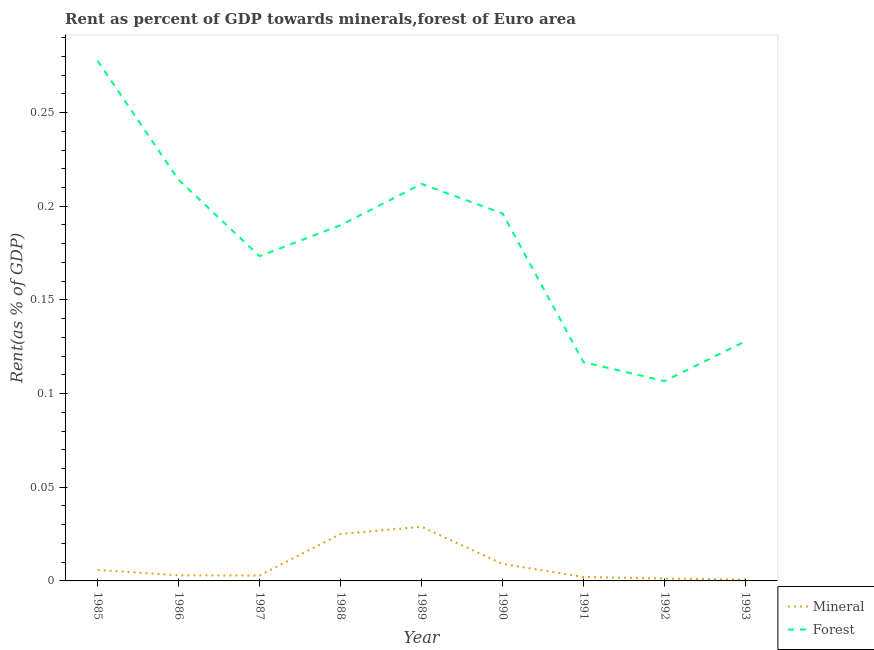How many different coloured lines are there?
Your answer should be very brief. 2. What is the forest rent in 1986?
Your answer should be compact. 0.21. Across all years, what is the maximum forest rent?
Provide a succinct answer. 0.28. Across all years, what is the minimum forest rent?
Your answer should be compact. 0.11. In which year was the mineral rent maximum?
Offer a terse response. 1989. What is the total mineral rent in the graph?
Offer a very short reply. 0.08. What is the difference between the mineral rent in 1986 and that in 1987?
Give a very brief answer. 0. What is the difference between the mineral rent in 1989 and the forest rent in 1988?
Your answer should be very brief. -0.16. What is the average forest rent per year?
Make the answer very short. 0.18. In the year 1993, what is the difference between the forest rent and mineral rent?
Keep it short and to the point. 0.13. In how many years, is the mineral rent greater than 0.18000000000000002 %?
Your answer should be very brief. 0. What is the ratio of the forest rent in 1986 to that in 1987?
Give a very brief answer. 1.23. Is the mineral rent in 1987 less than that in 1988?
Your answer should be compact. Yes. What is the difference between the highest and the second highest forest rent?
Ensure brevity in your answer.  0.06. What is the difference between the highest and the lowest forest rent?
Offer a terse response. 0.17. In how many years, is the forest rent greater than the average forest rent taken over all years?
Offer a very short reply. 5. Does the forest rent monotonically increase over the years?
Your answer should be very brief. No. Is the mineral rent strictly less than the forest rent over the years?
Your response must be concise. Yes. How many years are there in the graph?
Give a very brief answer. 9. Where does the legend appear in the graph?
Give a very brief answer. Bottom right. What is the title of the graph?
Offer a very short reply. Rent as percent of GDP towards minerals,forest of Euro area. What is the label or title of the Y-axis?
Your answer should be compact. Rent(as % of GDP). What is the Rent(as % of GDP) in Mineral in 1985?
Ensure brevity in your answer.  0.01. What is the Rent(as % of GDP) of Forest in 1985?
Make the answer very short. 0.28. What is the Rent(as % of GDP) of Mineral in 1986?
Your answer should be compact. 0. What is the Rent(as % of GDP) of Forest in 1986?
Your answer should be compact. 0.21. What is the Rent(as % of GDP) in Mineral in 1987?
Make the answer very short. 0. What is the Rent(as % of GDP) in Forest in 1987?
Your answer should be very brief. 0.17. What is the Rent(as % of GDP) of Mineral in 1988?
Keep it short and to the point. 0.03. What is the Rent(as % of GDP) of Forest in 1988?
Offer a very short reply. 0.19. What is the Rent(as % of GDP) in Mineral in 1989?
Make the answer very short. 0.03. What is the Rent(as % of GDP) of Forest in 1989?
Provide a succinct answer. 0.21. What is the Rent(as % of GDP) in Mineral in 1990?
Offer a terse response. 0.01. What is the Rent(as % of GDP) of Forest in 1990?
Ensure brevity in your answer.  0.2. What is the Rent(as % of GDP) of Mineral in 1991?
Keep it short and to the point. 0. What is the Rent(as % of GDP) of Forest in 1991?
Ensure brevity in your answer.  0.12. What is the Rent(as % of GDP) in Mineral in 1992?
Give a very brief answer. 0. What is the Rent(as % of GDP) in Forest in 1992?
Your answer should be very brief. 0.11. What is the Rent(as % of GDP) of Mineral in 1993?
Provide a short and direct response. 0. What is the Rent(as % of GDP) in Forest in 1993?
Provide a short and direct response. 0.13. Across all years, what is the maximum Rent(as % of GDP) of Mineral?
Your response must be concise. 0.03. Across all years, what is the maximum Rent(as % of GDP) in Forest?
Ensure brevity in your answer.  0.28. Across all years, what is the minimum Rent(as % of GDP) in Mineral?
Provide a succinct answer. 0. Across all years, what is the minimum Rent(as % of GDP) in Forest?
Provide a short and direct response. 0.11. What is the total Rent(as % of GDP) of Mineral in the graph?
Ensure brevity in your answer.  0.08. What is the total Rent(as % of GDP) of Forest in the graph?
Provide a short and direct response. 1.61. What is the difference between the Rent(as % of GDP) in Mineral in 1985 and that in 1986?
Provide a short and direct response. 0. What is the difference between the Rent(as % of GDP) in Forest in 1985 and that in 1986?
Make the answer very short. 0.06. What is the difference between the Rent(as % of GDP) in Mineral in 1985 and that in 1987?
Provide a short and direct response. 0. What is the difference between the Rent(as % of GDP) in Forest in 1985 and that in 1987?
Your answer should be compact. 0.1. What is the difference between the Rent(as % of GDP) in Mineral in 1985 and that in 1988?
Give a very brief answer. -0.02. What is the difference between the Rent(as % of GDP) in Forest in 1985 and that in 1988?
Provide a succinct answer. 0.09. What is the difference between the Rent(as % of GDP) in Mineral in 1985 and that in 1989?
Ensure brevity in your answer.  -0.02. What is the difference between the Rent(as % of GDP) of Forest in 1985 and that in 1989?
Offer a very short reply. 0.07. What is the difference between the Rent(as % of GDP) in Mineral in 1985 and that in 1990?
Ensure brevity in your answer.  -0. What is the difference between the Rent(as % of GDP) in Forest in 1985 and that in 1990?
Your response must be concise. 0.08. What is the difference between the Rent(as % of GDP) of Mineral in 1985 and that in 1991?
Offer a terse response. 0. What is the difference between the Rent(as % of GDP) of Forest in 1985 and that in 1991?
Offer a terse response. 0.16. What is the difference between the Rent(as % of GDP) of Mineral in 1985 and that in 1992?
Provide a succinct answer. 0. What is the difference between the Rent(as % of GDP) of Forest in 1985 and that in 1992?
Provide a short and direct response. 0.17. What is the difference between the Rent(as % of GDP) of Mineral in 1985 and that in 1993?
Provide a short and direct response. 0.01. What is the difference between the Rent(as % of GDP) in Forest in 1985 and that in 1993?
Ensure brevity in your answer.  0.15. What is the difference between the Rent(as % of GDP) of Mineral in 1986 and that in 1987?
Your response must be concise. 0. What is the difference between the Rent(as % of GDP) in Forest in 1986 and that in 1987?
Provide a succinct answer. 0.04. What is the difference between the Rent(as % of GDP) of Mineral in 1986 and that in 1988?
Your answer should be compact. -0.02. What is the difference between the Rent(as % of GDP) in Forest in 1986 and that in 1988?
Make the answer very short. 0.02. What is the difference between the Rent(as % of GDP) in Mineral in 1986 and that in 1989?
Provide a short and direct response. -0.03. What is the difference between the Rent(as % of GDP) in Forest in 1986 and that in 1989?
Your answer should be very brief. 0. What is the difference between the Rent(as % of GDP) in Mineral in 1986 and that in 1990?
Give a very brief answer. -0.01. What is the difference between the Rent(as % of GDP) of Forest in 1986 and that in 1990?
Make the answer very short. 0.02. What is the difference between the Rent(as % of GDP) of Mineral in 1986 and that in 1991?
Provide a succinct answer. 0. What is the difference between the Rent(as % of GDP) of Forest in 1986 and that in 1991?
Make the answer very short. 0.1. What is the difference between the Rent(as % of GDP) in Mineral in 1986 and that in 1992?
Your answer should be very brief. 0. What is the difference between the Rent(as % of GDP) in Forest in 1986 and that in 1992?
Offer a very short reply. 0.11. What is the difference between the Rent(as % of GDP) in Mineral in 1986 and that in 1993?
Keep it short and to the point. 0. What is the difference between the Rent(as % of GDP) of Forest in 1986 and that in 1993?
Offer a terse response. 0.09. What is the difference between the Rent(as % of GDP) of Mineral in 1987 and that in 1988?
Provide a succinct answer. -0.02. What is the difference between the Rent(as % of GDP) in Forest in 1987 and that in 1988?
Your answer should be very brief. -0.02. What is the difference between the Rent(as % of GDP) in Mineral in 1987 and that in 1989?
Provide a succinct answer. -0.03. What is the difference between the Rent(as % of GDP) of Forest in 1987 and that in 1989?
Give a very brief answer. -0.04. What is the difference between the Rent(as % of GDP) of Mineral in 1987 and that in 1990?
Keep it short and to the point. -0.01. What is the difference between the Rent(as % of GDP) in Forest in 1987 and that in 1990?
Provide a short and direct response. -0.02. What is the difference between the Rent(as % of GDP) in Mineral in 1987 and that in 1991?
Ensure brevity in your answer.  0. What is the difference between the Rent(as % of GDP) of Forest in 1987 and that in 1991?
Offer a very short reply. 0.06. What is the difference between the Rent(as % of GDP) in Mineral in 1987 and that in 1992?
Give a very brief answer. 0. What is the difference between the Rent(as % of GDP) in Forest in 1987 and that in 1992?
Keep it short and to the point. 0.07. What is the difference between the Rent(as % of GDP) in Mineral in 1987 and that in 1993?
Your answer should be very brief. 0. What is the difference between the Rent(as % of GDP) of Forest in 1987 and that in 1993?
Your answer should be compact. 0.05. What is the difference between the Rent(as % of GDP) of Mineral in 1988 and that in 1989?
Make the answer very short. -0. What is the difference between the Rent(as % of GDP) of Forest in 1988 and that in 1989?
Provide a short and direct response. -0.02. What is the difference between the Rent(as % of GDP) of Mineral in 1988 and that in 1990?
Offer a very short reply. 0.02. What is the difference between the Rent(as % of GDP) in Forest in 1988 and that in 1990?
Offer a very short reply. -0.01. What is the difference between the Rent(as % of GDP) in Mineral in 1988 and that in 1991?
Your answer should be very brief. 0.02. What is the difference between the Rent(as % of GDP) in Forest in 1988 and that in 1991?
Give a very brief answer. 0.07. What is the difference between the Rent(as % of GDP) in Mineral in 1988 and that in 1992?
Offer a terse response. 0.02. What is the difference between the Rent(as % of GDP) in Forest in 1988 and that in 1992?
Make the answer very short. 0.08. What is the difference between the Rent(as % of GDP) in Mineral in 1988 and that in 1993?
Your answer should be very brief. 0.02. What is the difference between the Rent(as % of GDP) of Forest in 1988 and that in 1993?
Provide a succinct answer. 0.06. What is the difference between the Rent(as % of GDP) in Mineral in 1989 and that in 1990?
Your answer should be very brief. 0.02. What is the difference between the Rent(as % of GDP) of Forest in 1989 and that in 1990?
Offer a terse response. 0.02. What is the difference between the Rent(as % of GDP) in Mineral in 1989 and that in 1991?
Offer a terse response. 0.03. What is the difference between the Rent(as % of GDP) in Forest in 1989 and that in 1991?
Offer a terse response. 0.1. What is the difference between the Rent(as % of GDP) in Mineral in 1989 and that in 1992?
Your response must be concise. 0.03. What is the difference between the Rent(as % of GDP) of Forest in 1989 and that in 1992?
Your answer should be compact. 0.11. What is the difference between the Rent(as % of GDP) in Mineral in 1989 and that in 1993?
Your answer should be compact. 0.03. What is the difference between the Rent(as % of GDP) of Forest in 1989 and that in 1993?
Give a very brief answer. 0.08. What is the difference between the Rent(as % of GDP) of Mineral in 1990 and that in 1991?
Give a very brief answer. 0.01. What is the difference between the Rent(as % of GDP) in Forest in 1990 and that in 1991?
Provide a short and direct response. 0.08. What is the difference between the Rent(as % of GDP) in Mineral in 1990 and that in 1992?
Give a very brief answer. 0.01. What is the difference between the Rent(as % of GDP) in Forest in 1990 and that in 1992?
Your answer should be compact. 0.09. What is the difference between the Rent(as % of GDP) in Mineral in 1990 and that in 1993?
Provide a short and direct response. 0.01. What is the difference between the Rent(as % of GDP) in Forest in 1990 and that in 1993?
Make the answer very short. 0.07. What is the difference between the Rent(as % of GDP) in Mineral in 1991 and that in 1992?
Your response must be concise. 0. What is the difference between the Rent(as % of GDP) of Forest in 1991 and that in 1992?
Your response must be concise. 0.01. What is the difference between the Rent(as % of GDP) in Mineral in 1991 and that in 1993?
Offer a terse response. 0. What is the difference between the Rent(as % of GDP) in Forest in 1991 and that in 1993?
Give a very brief answer. -0.01. What is the difference between the Rent(as % of GDP) in Mineral in 1992 and that in 1993?
Your answer should be very brief. 0. What is the difference between the Rent(as % of GDP) of Forest in 1992 and that in 1993?
Provide a succinct answer. -0.02. What is the difference between the Rent(as % of GDP) of Mineral in 1985 and the Rent(as % of GDP) of Forest in 1986?
Your answer should be very brief. -0.21. What is the difference between the Rent(as % of GDP) of Mineral in 1985 and the Rent(as % of GDP) of Forest in 1987?
Offer a very short reply. -0.17. What is the difference between the Rent(as % of GDP) of Mineral in 1985 and the Rent(as % of GDP) of Forest in 1988?
Make the answer very short. -0.18. What is the difference between the Rent(as % of GDP) of Mineral in 1985 and the Rent(as % of GDP) of Forest in 1989?
Offer a terse response. -0.21. What is the difference between the Rent(as % of GDP) of Mineral in 1985 and the Rent(as % of GDP) of Forest in 1990?
Make the answer very short. -0.19. What is the difference between the Rent(as % of GDP) of Mineral in 1985 and the Rent(as % of GDP) of Forest in 1991?
Your answer should be compact. -0.11. What is the difference between the Rent(as % of GDP) of Mineral in 1985 and the Rent(as % of GDP) of Forest in 1992?
Offer a terse response. -0.1. What is the difference between the Rent(as % of GDP) of Mineral in 1985 and the Rent(as % of GDP) of Forest in 1993?
Keep it short and to the point. -0.12. What is the difference between the Rent(as % of GDP) in Mineral in 1986 and the Rent(as % of GDP) in Forest in 1987?
Offer a terse response. -0.17. What is the difference between the Rent(as % of GDP) of Mineral in 1986 and the Rent(as % of GDP) of Forest in 1988?
Provide a succinct answer. -0.19. What is the difference between the Rent(as % of GDP) in Mineral in 1986 and the Rent(as % of GDP) in Forest in 1989?
Keep it short and to the point. -0.21. What is the difference between the Rent(as % of GDP) of Mineral in 1986 and the Rent(as % of GDP) of Forest in 1990?
Your answer should be compact. -0.19. What is the difference between the Rent(as % of GDP) in Mineral in 1986 and the Rent(as % of GDP) in Forest in 1991?
Offer a very short reply. -0.11. What is the difference between the Rent(as % of GDP) of Mineral in 1986 and the Rent(as % of GDP) of Forest in 1992?
Give a very brief answer. -0.1. What is the difference between the Rent(as % of GDP) in Mineral in 1986 and the Rent(as % of GDP) in Forest in 1993?
Offer a very short reply. -0.12. What is the difference between the Rent(as % of GDP) of Mineral in 1987 and the Rent(as % of GDP) of Forest in 1988?
Your answer should be compact. -0.19. What is the difference between the Rent(as % of GDP) in Mineral in 1987 and the Rent(as % of GDP) in Forest in 1989?
Ensure brevity in your answer.  -0.21. What is the difference between the Rent(as % of GDP) of Mineral in 1987 and the Rent(as % of GDP) of Forest in 1990?
Keep it short and to the point. -0.19. What is the difference between the Rent(as % of GDP) in Mineral in 1987 and the Rent(as % of GDP) in Forest in 1991?
Provide a short and direct response. -0.11. What is the difference between the Rent(as % of GDP) in Mineral in 1987 and the Rent(as % of GDP) in Forest in 1992?
Make the answer very short. -0.1. What is the difference between the Rent(as % of GDP) of Mineral in 1987 and the Rent(as % of GDP) of Forest in 1993?
Your answer should be very brief. -0.13. What is the difference between the Rent(as % of GDP) in Mineral in 1988 and the Rent(as % of GDP) in Forest in 1989?
Provide a succinct answer. -0.19. What is the difference between the Rent(as % of GDP) of Mineral in 1988 and the Rent(as % of GDP) of Forest in 1990?
Your response must be concise. -0.17. What is the difference between the Rent(as % of GDP) in Mineral in 1988 and the Rent(as % of GDP) in Forest in 1991?
Offer a very short reply. -0.09. What is the difference between the Rent(as % of GDP) in Mineral in 1988 and the Rent(as % of GDP) in Forest in 1992?
Your response must be concise. -0.08. What is the difference between the Rent(as % of GDP) of Mineral in 1988 and the Rent(as % of GDP) of Forest in 1993?
Your answer should be very brief. -0.1. What is the difference between the Rent(as % of GDP) in Mineral in 1989 and the Rent(as % of GDP) in Forest in 1990?
Your response must be concise. -0.17. What is the difference between the Rent(as % of GDP) in Mineral in 1989 and the Rent(as % of GDP) in Forest in 1991?
Your answer should be compact. -0.09. What is the difference between the Rent(as % of GDP) of Mineral in 1989 and the Rent(as % of GDP) of Forest in 1992?
Give a very brief answer. -0.08. What is the difference between the Rent(as % of GDP) in Mineral in 1989 and the Rent(as % of GDP) in Forest in 1993?
Make the answer very short. -0.1. What is the difference between the Rent(as % of GDP) of Mineral in 1990 and the Rent(as % of GDP) of Forest in 1991?
Keep it short and to the point. -0.11. What is the difference between the Rent(as % of GDP) of Mineral in 1990 and the Rent(as % of GDP) of Forest in 1992?
Provide a succinct answer. -0.1. What is the difference between the Rent(as % of GDP) of Mineral in 1990 and the Rent(as % of GDP) of Forest in 1993?
Make the answer very short. -0.12. What is the difference between the Rent(as % of GDP) in Mineral in 1991 and the Rent(as % of GDP) in Forest in 1992?
Provide a succinct answer. -0.1. What is the difference between the Rent(as % of GDP) of Mineral in 1991 and the Rent(as % of GDP) of Forest in 1993?
Provide a succinct answer. -0.13. What is the difference between the Rent(as % of GDP) in Mineral in 1992 and the Rent(as % of GDP) in Forest in 1993?
Your answer should be very brief. -0.13. What is the average Rent(as % of GDP) of Mineral per year?
Ensure brevity in your answer.  0.01. What is the average Rent(as % of GDP) in Forest per year?
Your answer should be compact. 0.18. In the year 1985, what is the difference between the Rent(as % of GDP) in Mineral and Rent(as % of GDP) in Forest?
Offer a terse response. -0.27. In the year 1986, what is the difference between the Rent(as % of GDP) of Mineral and Rent(as % of GDP) of Forest?
Your answer should be compact. -0.21. In the year 1987, what is the difference between the Rent(as % of GDP) of Mineral and Rent(as % of GDP) of Forest?
Offer a terse response. -0.17. In the year 1988, what is the difference between the Rent(as % of GDP) in Mineral and Rent(as % of GDP) in Forest?
Ensure brevity in your answer.  -0.16. In the year 1989, what is the difference between the Rent(as % of GDP) in Mineral and Rent(as % of GDP) in Forest?
Provide a succinct answer. -0.18. In the year 1990, what is the difference between the Rent(as % of GDP) in Mineral and Rent(as % of GDP) in Forest?
Give a very brief answer. -0.19. In the year 1991, what is the difference between the Rent(as % of GDP) of Mineral and Rent(as % of GDP) of Forest?
Offer a very short reply. -0.11. In the year 1992, what is the difference between the Rent(as % of GDP) in Mineral and Rent(as % of GDP) in Forest?
Keep it short and to the point. -0.11. In the year 1993, what is the difference between the Rent(as % of GDP) of Mineral and Rent(as % of GDP) of Forest?
Offer a very short reply. -0.13. What is the ratio of the Rent(as % of GDP) in Mineral in 1985 to that in 1986?
Offer a terse response. 1.95. What is the ratio of the Rent(as % of GDP) of Forest in 1985 to that in 1986?
Provide a succinct answer. 1.3. What is the ratio of the Rent(as % of GDP) in Mineral in 1985 to that in 1987?
Offer a very short reply. 2.03. What is the ratio of the Rent(as % of GDP) in Forest in 1985 to that in 1987?
Make the answer very short. 1.6. What is the ratio of the Rent(as % of GDP) of Mineral in 1985 to that in 1988?
Offer a terse response. 0.23. What is the ratio of the Rent(as % of GDP) in Forest in 1985 to that in 1988?
Give a very brief answer. 1.46. What is the ratio of the Rent(as % of GDP) of Mineral in 1985 to that in 1989?
Provide a short and direct response. 0.2. What is the ratio of the Rent(as % of GDP) of Forest in 1985 to that in 1989?
Provide a short and direct response. 1.31. What is the ratio of the Rent(as % of GDP) in Mineral in 1985 to that in 1990?
Provide a succinct answer. 0.64. What is the ratio of the Rent(as % of GDP) in Forest in 1985 to that in 1990?
Provide a succinct answer. 1.42. What is the ratio of the Rent(as % of GDP) in Mineral in 1985 to that in 1991?
Your answer should be very brief. 2.77. What is the ratio of the Rent(as % of GDP) in Forest in 1985 to that in 1991?
Keep it short and to the point. 2.38. What is the ratio of the Rent(as % of GDP) of Mineral in 1985 to that in 1992?
Give a very brief answer. 4.55. What is the ratio of the Rent(as % of GDP) of Forest in 1985 to that in 1992?
Give a very brief answer. 2.6. What is the ratio of the Rent(as % of GDP) of Mineral in 1985 to that in 1993?
Offer a terse response. 8.27. What is the ratio of the Rent(as % of GDP) in Forest in 1985 to that in 1993?
Keep it short and to the point. 2.17. What is the ratio of the Rent(as % of GDP) in Mineral in 1986 to that in 1987?
Provide a short and direct response. 1.04. What is the ratio of the Rent(as % of GDP) in Forest in 1986 to that in 1987?
Provide a succinct answer. 1.23. What is the ratio of the Rent(as % of GDP) of Mineral in 1986 to that in 1988?
Make the answer very short. 0.12. What is the ratio of the Rent(as % of GDP) of Forest in 1986 to that in 1988?
Make the answer very short. 1.13. What is the ratio of the Rent(as % of GDP) in Mineral in 1986 to that in 1989?
Provide a succinct answer. 0.1. What is the ratio of the Rent(as % of GDP) of Forest in 1986 to that in 1989?
Offer a very short reply. 1.01. What is the ratio of the Rent(as % of GDP) in Mineral in 1986 to that in 1990?
Provide a succinct answer. 0.33. What is the ratio of the Rent(as % of GDP) of Forest in 1986 to that in 1990?
Make the answer very short. 1.09. What is the ratio of the Rent(as % of GDP) in Mineral in 1986 to that in 1991?
Offer a very short reply. 1.42. What is the ratio of the Rent(as % of GDP) in Forest in 1986 to that in 1991?
Your answer should be compact. 1.83. What is the ratio of the Rent(as % of GDP) of Mineral in 1986 to that in 1992?
Provide a short and direct response. 2.34. What is the ratio of the Rent(as % of GDP) of Forest in 1986 to that in 1992?
Provide a succinct answer. 2.01. What is the ratio of the Rent(as % of GDP) in Mineral in 1986 to that in 1993?
Provide a short and direct response. 4.25. What is the ratio of the Rent(as % of GDP) in Forest in 1986 to that in 1993?
Provide a short and direct response. 1.67. What is the ratio of the Rent(as % of GDP) in Mineral in 1987 to that in 1988?
Keep it short and to the point. 0.12. What is the ratio of the Rent(as % of GDP) of Forest in 1987 to that in 1988?
Provide a short and direct response. 0.91. What is the ratio of the Rent(as % of GDP) in Mineral in 1987 to that in 1989?
Offer a very short reply. 0.1. What is the ratio of the Rent(as % of GDP) of Forest in 1987 to that in 1989?
Offer a terse response. 0.82. What is the ratio of the Rent(as % of GDP) of Mineral in 1987 to that in 1990?
Give a very brief answer. 0.32. What is the ratio of the Rent(as % of GDP) of Forest in 1987 to that in 1990?
Offer a very short reply. 0.88. What is the ratio of the Rent(as % of GDP) in Mineral in 1987 to that in 1991?
Make the answer very short. 1.37. What is the ratio of the Rent(as % of GDP) of Forest in 1987 to that in 1991?
Ensure brevity in your answer.  1.48. What is the ratio of the Rent(as % of GDP) in Mineral in 1987 to that in 1992?
Offer a terse response. 2.25. What is the ratio of the Rent(as % of GDP) in Forest in 1987 to that in 1992?
Your answer should be compact. 1.63. What is the ratio of the Rent(as % of GDP) of Mineral in 1987 to that in 1993?
Ensure brevity in your answer.  4.08. What is the ratio of the Rent(as % of GDP) of Forest in 1987 to that in 1993?
Make the answer very short. 1.35. What is the ratio of the Rent(as % of GDP) of Mineral in 1988 to that in 1989?
Ensure brevity in your answer.  0.87. What is the ratio of the Rent(as % of GDP) in Forest in 1988 to that in 1989?
Your response must be concise. 0.9. What is the ratio of the Rent(as % of GDP) in Mineral in 1988 to that in 1990?
Ensure brevity in your answer.  2.76. What is the ratio of the Rent(as % of GDP) in Mineral in 1988 to that in 1991?
Your answer should be compact. 11.89. What is the ratio of the Rent(as % of GDP) in Forest in 1988 to that in 1991?
Your response must be concise. 1.63. What is the ratio of the Rent(as % of GDP) of Mineral in 1988 to that in 1992?
Make the answer very short. 19.52. What is the ratio of the Rent(as % of GDP) in Forest in 1988 to that in 1992?
Provide a short and direct response. 1.78. What is the ratio of the Rent(as % of GDP) in Mineral in 1988 to that in 1993?
Your answer should be compact. 35.45. What is the ratio of the Rent(as % of GDP) of Forest in 1988 to that in 1993?
Your answer should be compact. 1.48. What is the ratio of the Rent(as % of GDP) in Mineral in 1989 to that in 1990?
Your answer should be very brief. 3.18. What is the ratio of the Rent(as % of GDP) of Forest in 1989 to that in 1990?
Give a very brief answer. 1.08. What is the ratio of the Rent(as % of GDP) in Mineral in 1989 to that in 1991?
Provide a short and direct response. 13.73. What is the ratio of the Rent(as % of GDP) of Forest in 1989 to that in 1991?
Provide a short and direct response. 1.81. What is the ratio of the Rent(as % of GDP) in Mineral in 1989 to that in 1992?
Keep it short and to the point. 22.55. What is the ratio of the Rent(as % of GDP) of Forest in 1989 to that in 1992?
Your response must be concise. 1.99. What is the ratio of the Rent(as % of GDP) of Mineral in 1989 to that in 1993?
Make the answer very short. 40.96. What is the ratio of the Rent(as % of GDP) in Forest in 1989 to that in 1993?
Give a very brief answer. 1.66. What is the ratio of the Rent(as % of GDP) in Mineral in 1990 to that in 1991?
Your answer should be very brief. 4.31. What is the ratio of the Rent(as % of GDP) of Forest in 1990 to that in 1991?
Your answer should be compact. 1.68. What is the ratio of the Rent(as % of GDP) in Mineral in 1990 to that in 1992?
Give a very brief answer. 7.08. What is the ratio of the Rent(as % of GDP) in Forest in 1990 to that in 1992?
Your answer should be compact. 1.84. What is the ratio of the Rent(as % of GDP) in Mineral in 1990 to that in 1993?
Your answer should be very brief. 12.86. What is the ratio of the Rent(as % of GDP) in Forest in 1990 to that in 1993?
Keep it short and to the point. 1.53. What is the ratio of the Rent(as % of GDP) of Mineral in 1991 to that in 1992?
Your answer should be very brief. 1.64. What is the ratio of the Rent(as % of GDP) in Forest in 1991 to that in 1992?
Your answer should be compact. 1.09. What is the ratio of the Rent(as % of GDP) in Mineral in 1991 to that in 1993?
Your response must be concise. 2.98. What is the ratio of the Rent(as % of GDP) of Forest in 1991 to that in 1993?
Give a very brief answer. 0.91. What is the ratio of the Rent(as % of GDP) of Mineral in 1992 to that in 1993?
Offer a very short reply. 1.82. What is the ratio of the Rent(as % of GDP) in Forest in 1992 to that in 1993?
Your response must be concise. 0.83. What is the difference between the highest and the second highest Rent(as % of GDP) of Mineral?
Ensure brevity in your answer.  0. What is the difference between the highest and the second highest Rent(as % of GDP) in Forest?
Make the answer very short. 0.06. What is the difference between the highest and the lowest Rent(as % of GDP) of Mineral?
Your answer should be very brief. 0.03. What is the difference between the highest and the lowest Rent(as % of GDP) of Forest?
Offer a terse response. 0.17. 